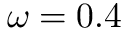<formula> <loc_0><loc_0><loc_500><loc_500>\omega = 0 . 4</formula> 